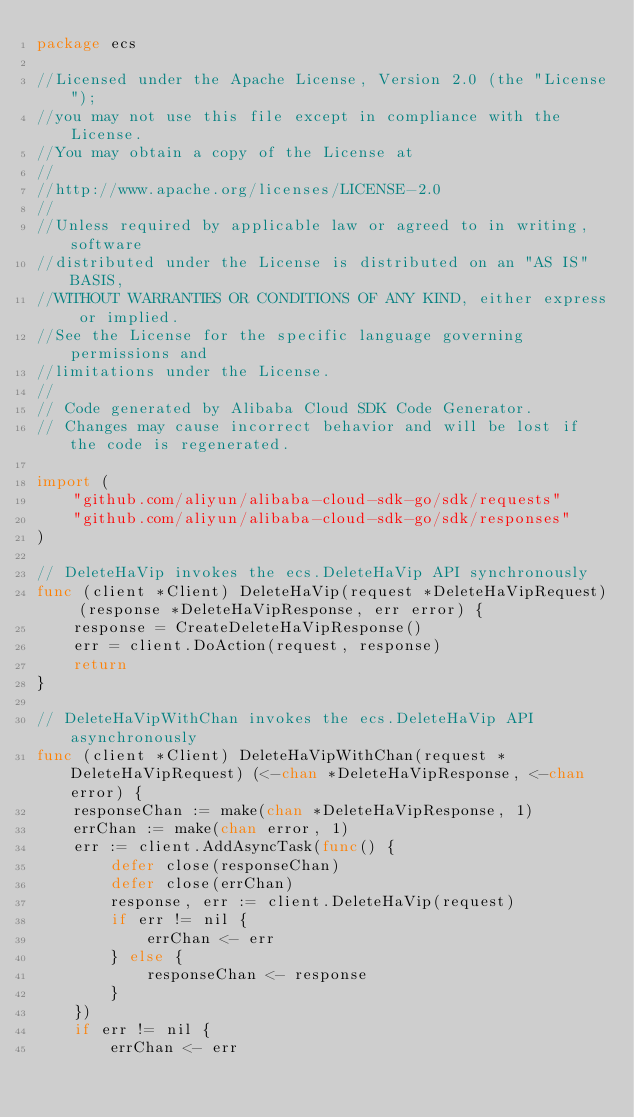Convert code to text. <code><loc_0><loc_0><loc_500><loc_500><_Go_>package ecs

//Licensed under the Apache License, Version 2.0 (the "License");
//you may not use this file except in compliance with the License.
//You may obtain a copy of the License at
//
//http://www.apache.org/licenses/LICENSE-2.0
//
//Unless required by applicable law or agreed to in writing, software
//distributed under the License is distributed on an "AS IS" BASIS,
//WITHOUT WARRANTIES OR CONDITIONS OF ANY KIND, either express or implied.
//See the License for the specific language governing permissions and
//limitations under the License.
//
// Code generated by Alibaba Cloud SDK Code Generator.
// Changes may cause incorrect behavior and will be lost if the code is regenerated.

import (
	"github.com/aliyun/alibaba-cloud-sdk-go/sdk/requests"
	"github.com/aliyun/alibaba-cloud-sdk-go/sdk/responses"
)

// DeleteHaVip invokes the ecs.DeleteHaVip API synchronously
func (client *Client) DeleteHaVip(request *DeleteHaVipRequest) (response *DeleteHaVipResponse, err error) {
	response = CreateDeleteHaVipResponse()
	err = client.DoAction(request, response)
	return
}

// DeleteHaVipWithChan invokes the ecs.DeleteHaVip API asynchronously
func (client *Client) DeleteHaVipWithChan(request *DeleteHaVipRequest) (<-chan *DeleteHaVipResponse, <-chan error) {
	responseChan := make(chan *DeleteHaVipResponse, 1)
	errChan := make(chan error, 1)
	err := client.AddAsyncTask(func() {
		defer close(responseChan)
		defer close(errChan)
		response, err := client.DeleteHaVip(request)
		if err != nil {
			errChan <- err
		} else {
			responseChan <- response
		}
	})
	if err != nil {
		errChan <- err</code> 